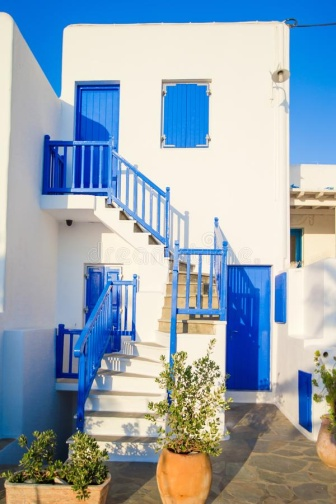How does the architectural style of this building reflect Mediterranean influences? The architectural style of this building reflects Mediterranean influences through its use of bright white paint that helps to reflect the hot sun, paired with vibrant blue accents typical of homes found in coastal regions of the Mediterranean. The flat roofing and the simplicity of the structural design also contribute to its Mediterranean aesthetic, providing a functional response to the warm, sunny climate of such regions. The outdoor staircase and balcony are characteristic features that enhance the open, airy feel of the architecture, inviting natural light and breezes into the home. 